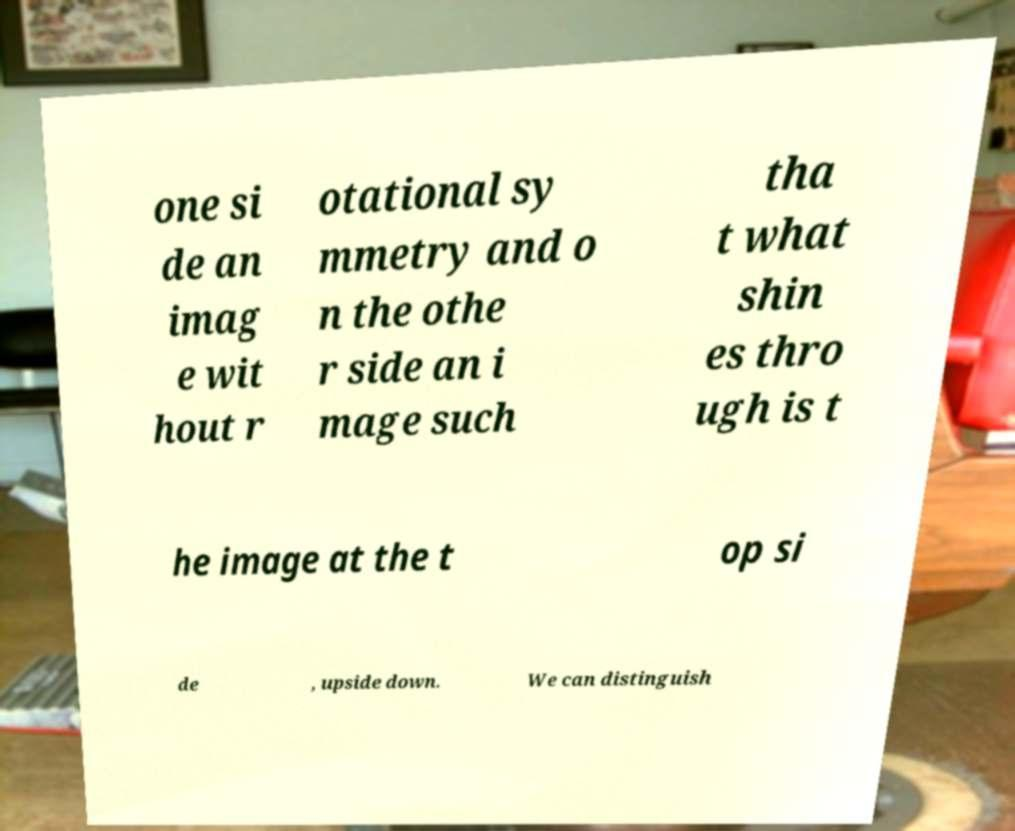I need the written content from this picture converted into text. Can you do that? one si de an imag e wit hout r otational sy mmetry and o n the othe r side an i mage such tha t what shin es thro ugh is t he image at the t op si de , upside down. We can distinguish 